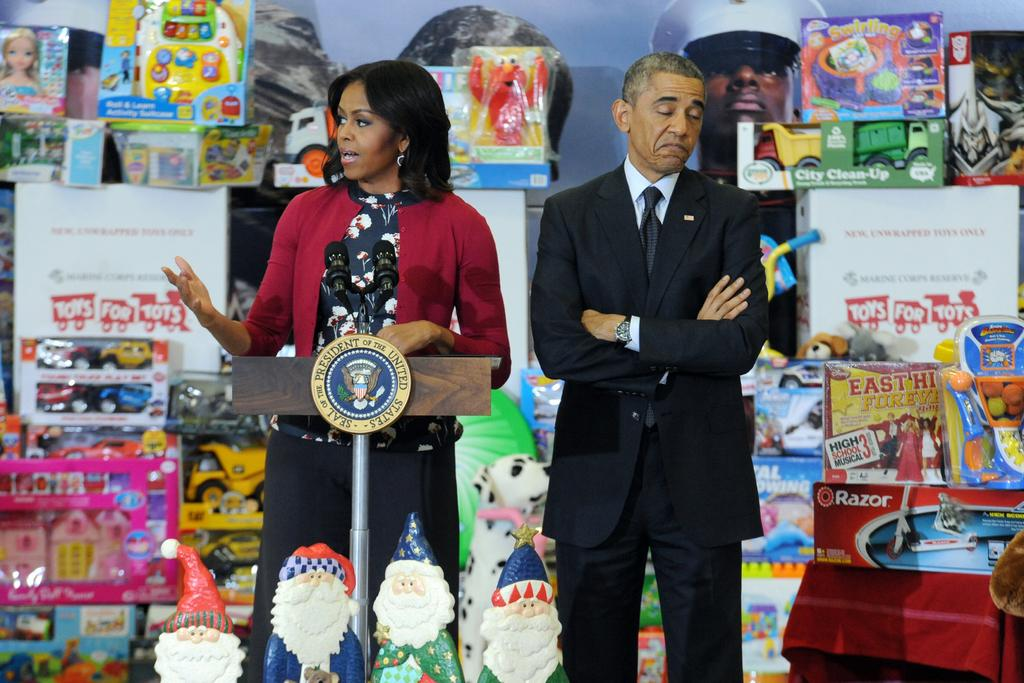Who is the main subject in the image? There is a woman in the image. What is the woman doing in the image? The woman is speaking into a microphone. Is there anyone else in the image? Yes, there is a man in the image. Where is the man located in relation to the woman? The man is beside the woman. What can be seen in the background of the image? There are many toys in the background of the image. What type of guitar is the woman playing in the image? There is no guitar present in the image; the woman is speaking into a microphone. Can you see any thread being used by the man in the image? There is no thread visible in the image; the man is standing beside the woman. 